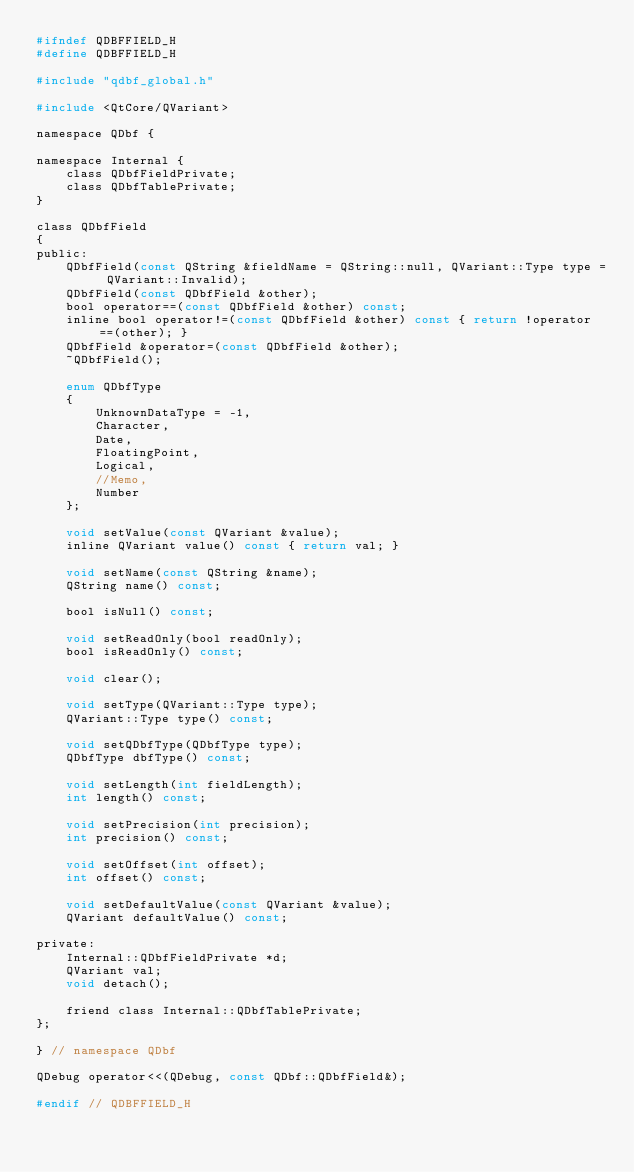Convert code to text. <code><loc_0><loc_0><loc_500><loc_500><_C_>#ifndef QDBFFIELD_H
#define QDBFFIELD_H

#include "qdbf_global.h"

#include <QtCore/QVariant>

namespace QDbf {

namespace Internal {
    class QDbfFieldPrivate;
    class QDbfTablePrivate;
}

class QDbfField
{
public:
    QDbfField(const QString &fieldName = QString::null, QVariant::Type type = QVariant::Invalid);
    QDbfField(const QDbfField &other);
    bool operator==(const QDbfField &other) const;
    inline bool operator!=(const QDbfField &other) const { return !operator==(other); }
    QDbfField &operator=(const QDbfField &other);
    ~QDbfField();

    enum QDbfType
    {
        UnknownDataType = -1,
        Character,
        Date,
        FloatingPoint,
        Logical,
        //Memo,
        Number
    };

    void setValue(const QVariant &value);
    inline QVariant value() const { return val; }

    void setName(const QString &name);
    QString name() const;

    bool isNull() const;

    void setReadOnly(bool readOnly);
    bool isReadOnly() const;

    void clear();

    void setType(QVariant::Type type);
    QVariant::Type type() const;

    void setQDbfType(QDbfType type);
    QDbfType dbfType() const;

    void setLength(int fieldLength);
    int length() const;

    void setPrecision(int precision);
    int precision() const;

    void setOffset(int offset);
    int offset() const;

    void setDefaultValue(const QVariant &value);
    QVariant defaultValue() const;

private:
    Internal::QDbfFieldPrivate *d;
    QVariant val;
    void detach();

    friend class Internal::QDbfTablePrivate;
};

} // namespace QDbf

QDebug operator<<(QDebug, const QDbf::QDbfField&);

#endif // QDBFFIELD_H
</code> 